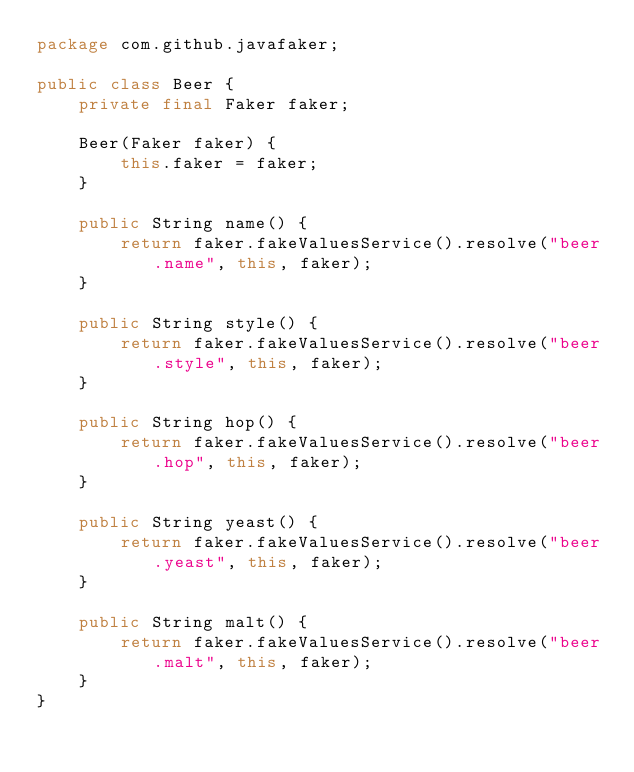<code> <loc_0><loc_0><loc_500><loc_500><_Java_>package com.github.javafaker;

public class Beer {
    private final Faker faker;

    Beer(Faker faker) {
        this.faker = faker;
    }

    public String name() {
        return faker.fakeValuesService().resolve("beer.name", this, faker);
    }

    public String style() {
        return faker.fakeValuesService().resolve("beer.style", this, faker);
    }

    public String hop() {
        return faker.fakeValuesService().resolve("beer.hop", this, faker);
    }

    public String yeast() {
        return faker.fakeValuesService().resolve("beer.yeast", this, faker);
    }

    public String malt() {
        return faker.fakeValuesService().resolve("beer.malt", this, faker);
    }
}
</code> 